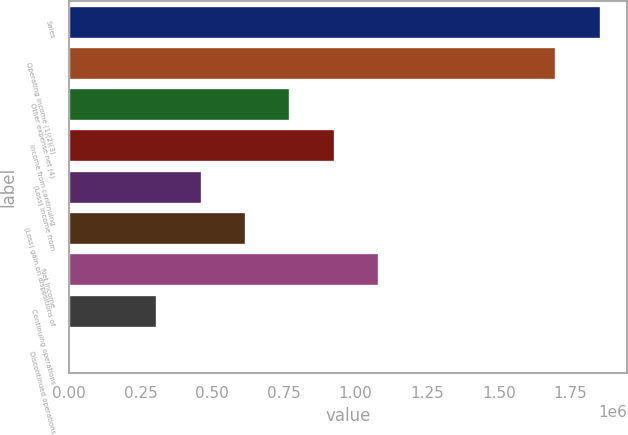<chart> <loc_0><loc_0><loc_500><loc_500><bar_chart><fcel>Sales<fcel>Operating income (1)(2)(3)<fcel>Other expense net (4)<fcel>Income from continuing<fcel>(Loss) income from<fcel>(Loss) gain on dispositions of<fcel>Net income<fcel>Continuing operations<fcel>Discontinued operations<nl><fcel>1.85563e+06<fcel>1.70099e+06<fcel>773179<fcel>927815<fcel>463907<fcel>618543<fcel>1.08245e+06<fcel>309272<fcel>0.01<nl></chart> 